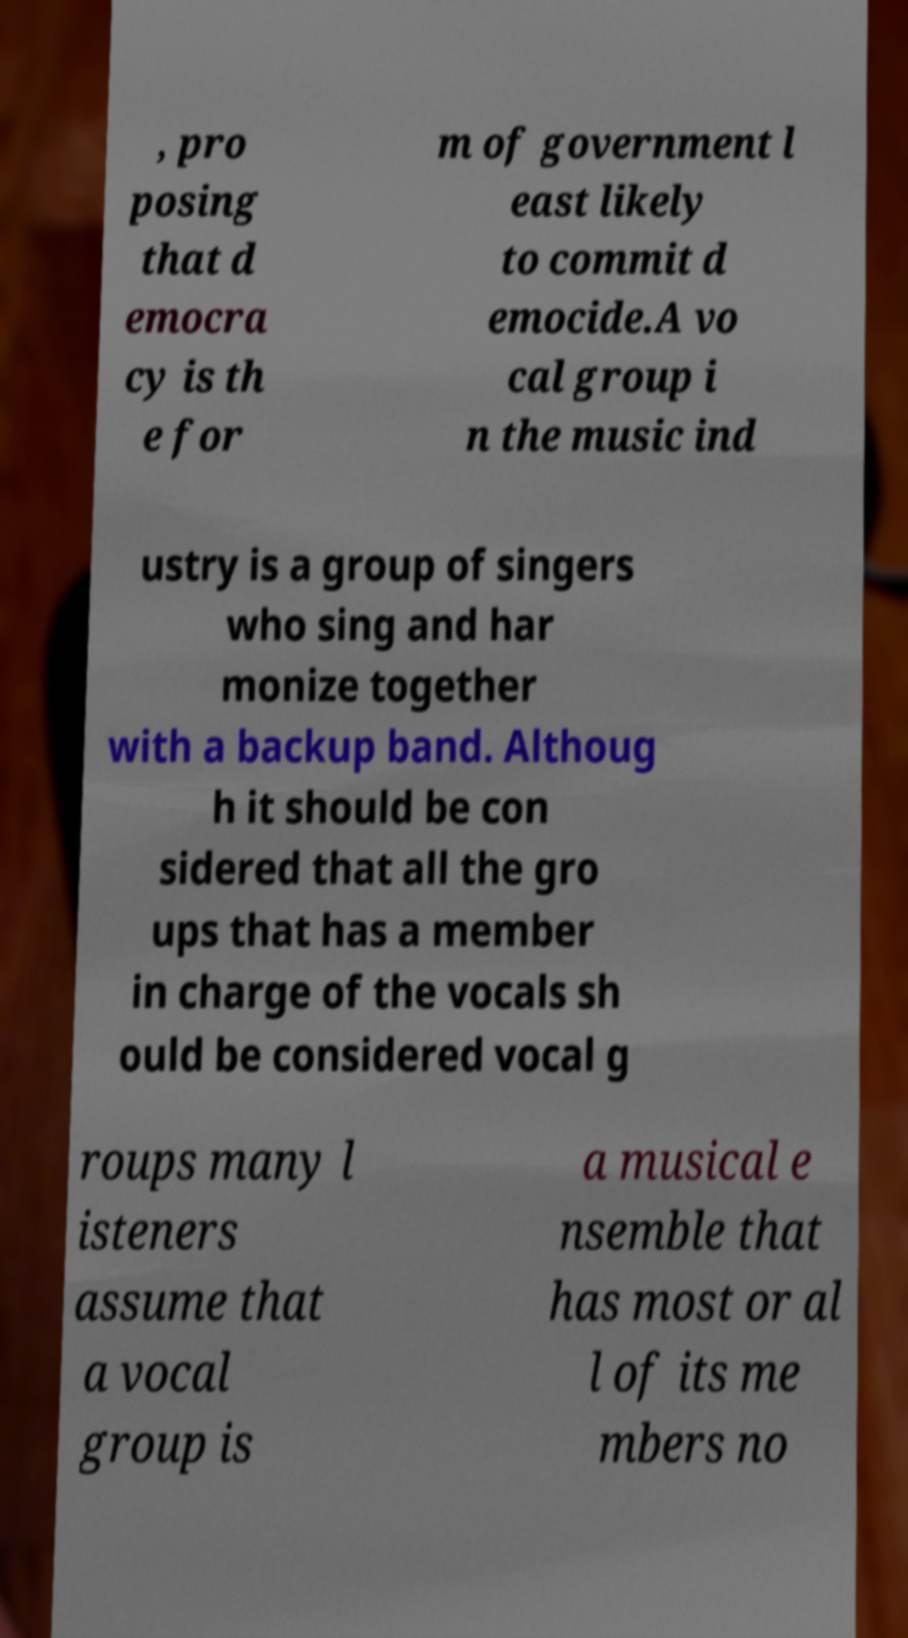Please identify and transcribe the text found in this image. , pro posing that d emocra cy is th e for m of government l east likely to commit d emocide.A vo cal group i n the music ind ustry is a group of singers who sing and har monize together with a backup band. Althoug h it should be con sidered that all the gro ups that has a member in charge of the vocals sh ould be considered vocal g roups many l isteners assume that a vocal group is a musical e nsemble that has most or al l of its me mbers no 